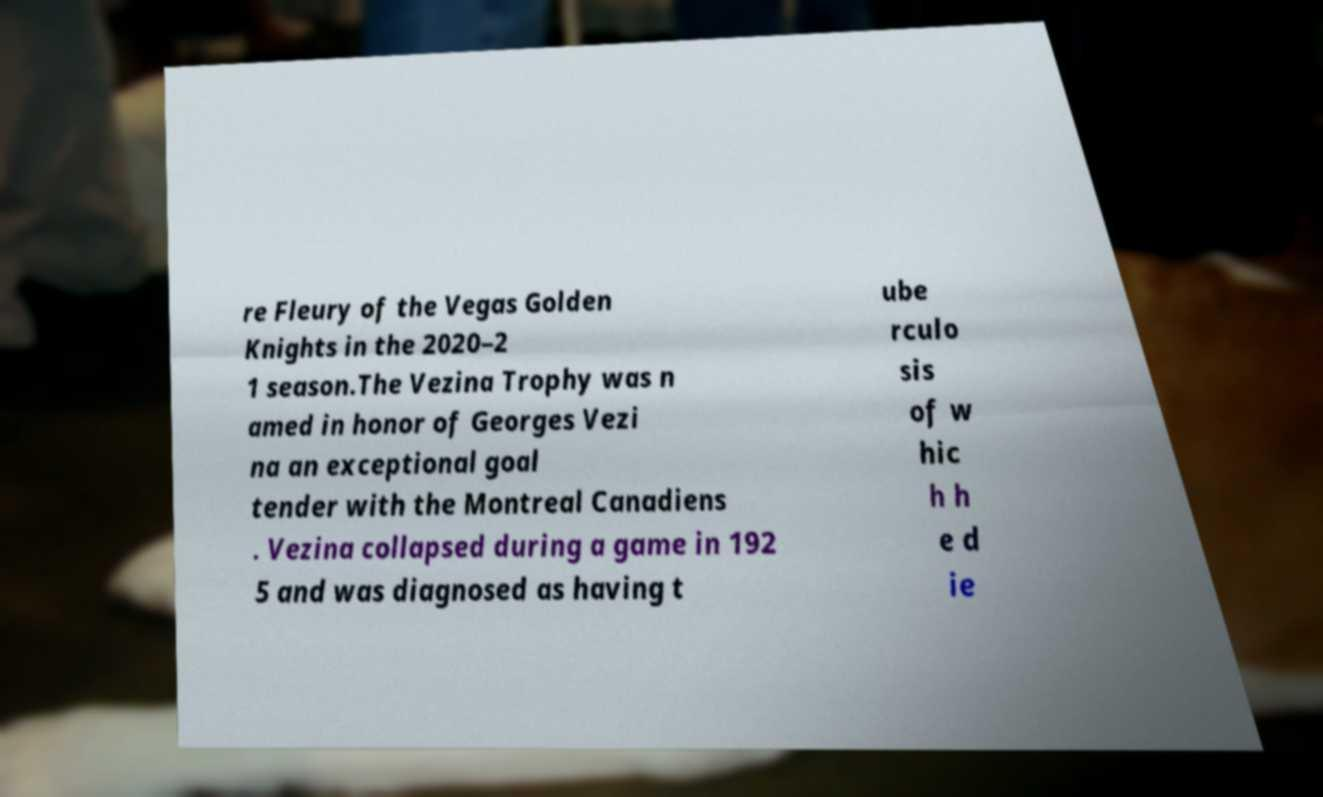What messages or text are displayed in this image? I need them in a readable, typed format. re Fleury of the Vegas Golden Knights in the 2020–2 1 season.The Vezina Trophy was n amed in honor of Georges Vezi na an exceptional goal tender with the Montreal Canadiens . Vezina collapsed during a game in 192 5 and was diagnosed as having t ube rculo sis of w hic h h e d ie 